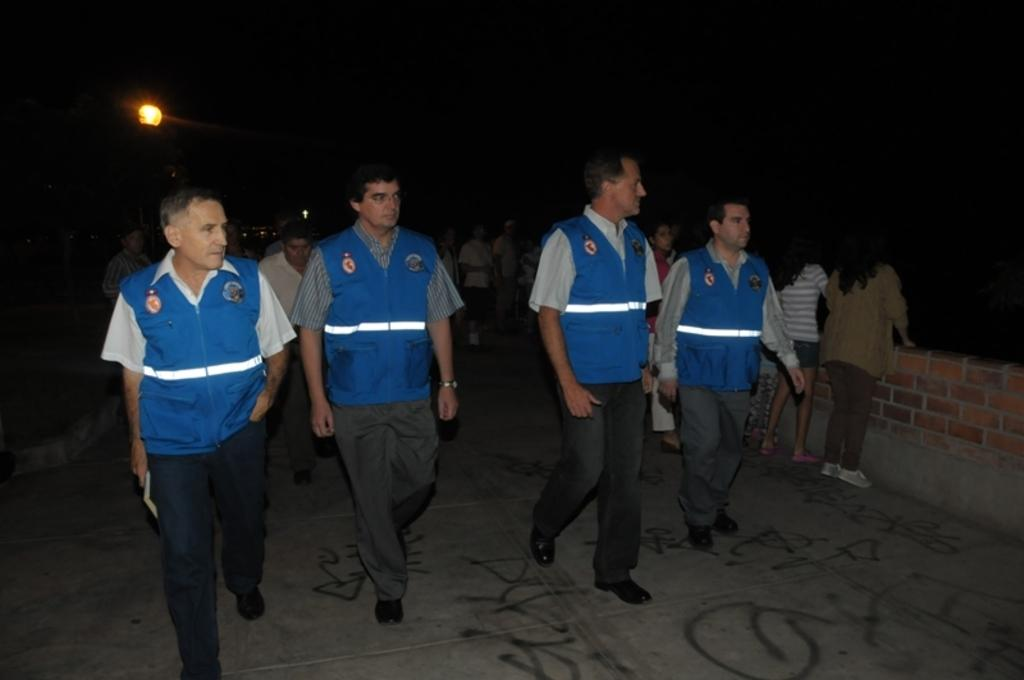What do the people in the image have in common? The people in the image are wearing the same shirts. How many ladies are in the image? There are two ladies in the image. What type of background is visible in the image? There is a brick wall in the image. What type of alarm is being used by the ladies in the image? There is no alarm present in the image; it only shows two ladies wearing matching shirts in front of a brick wall. 